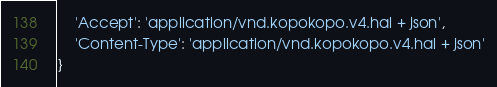Convert code to text. <code><loc_0><loc_0><loc_500><loc_500><_Python_>    'Accept': 'application/vnd.kopokopo.v4.hal + json',
    'Content-Type': 'application/vnd.kopokopo.v4.hal + json'
}
</code> 